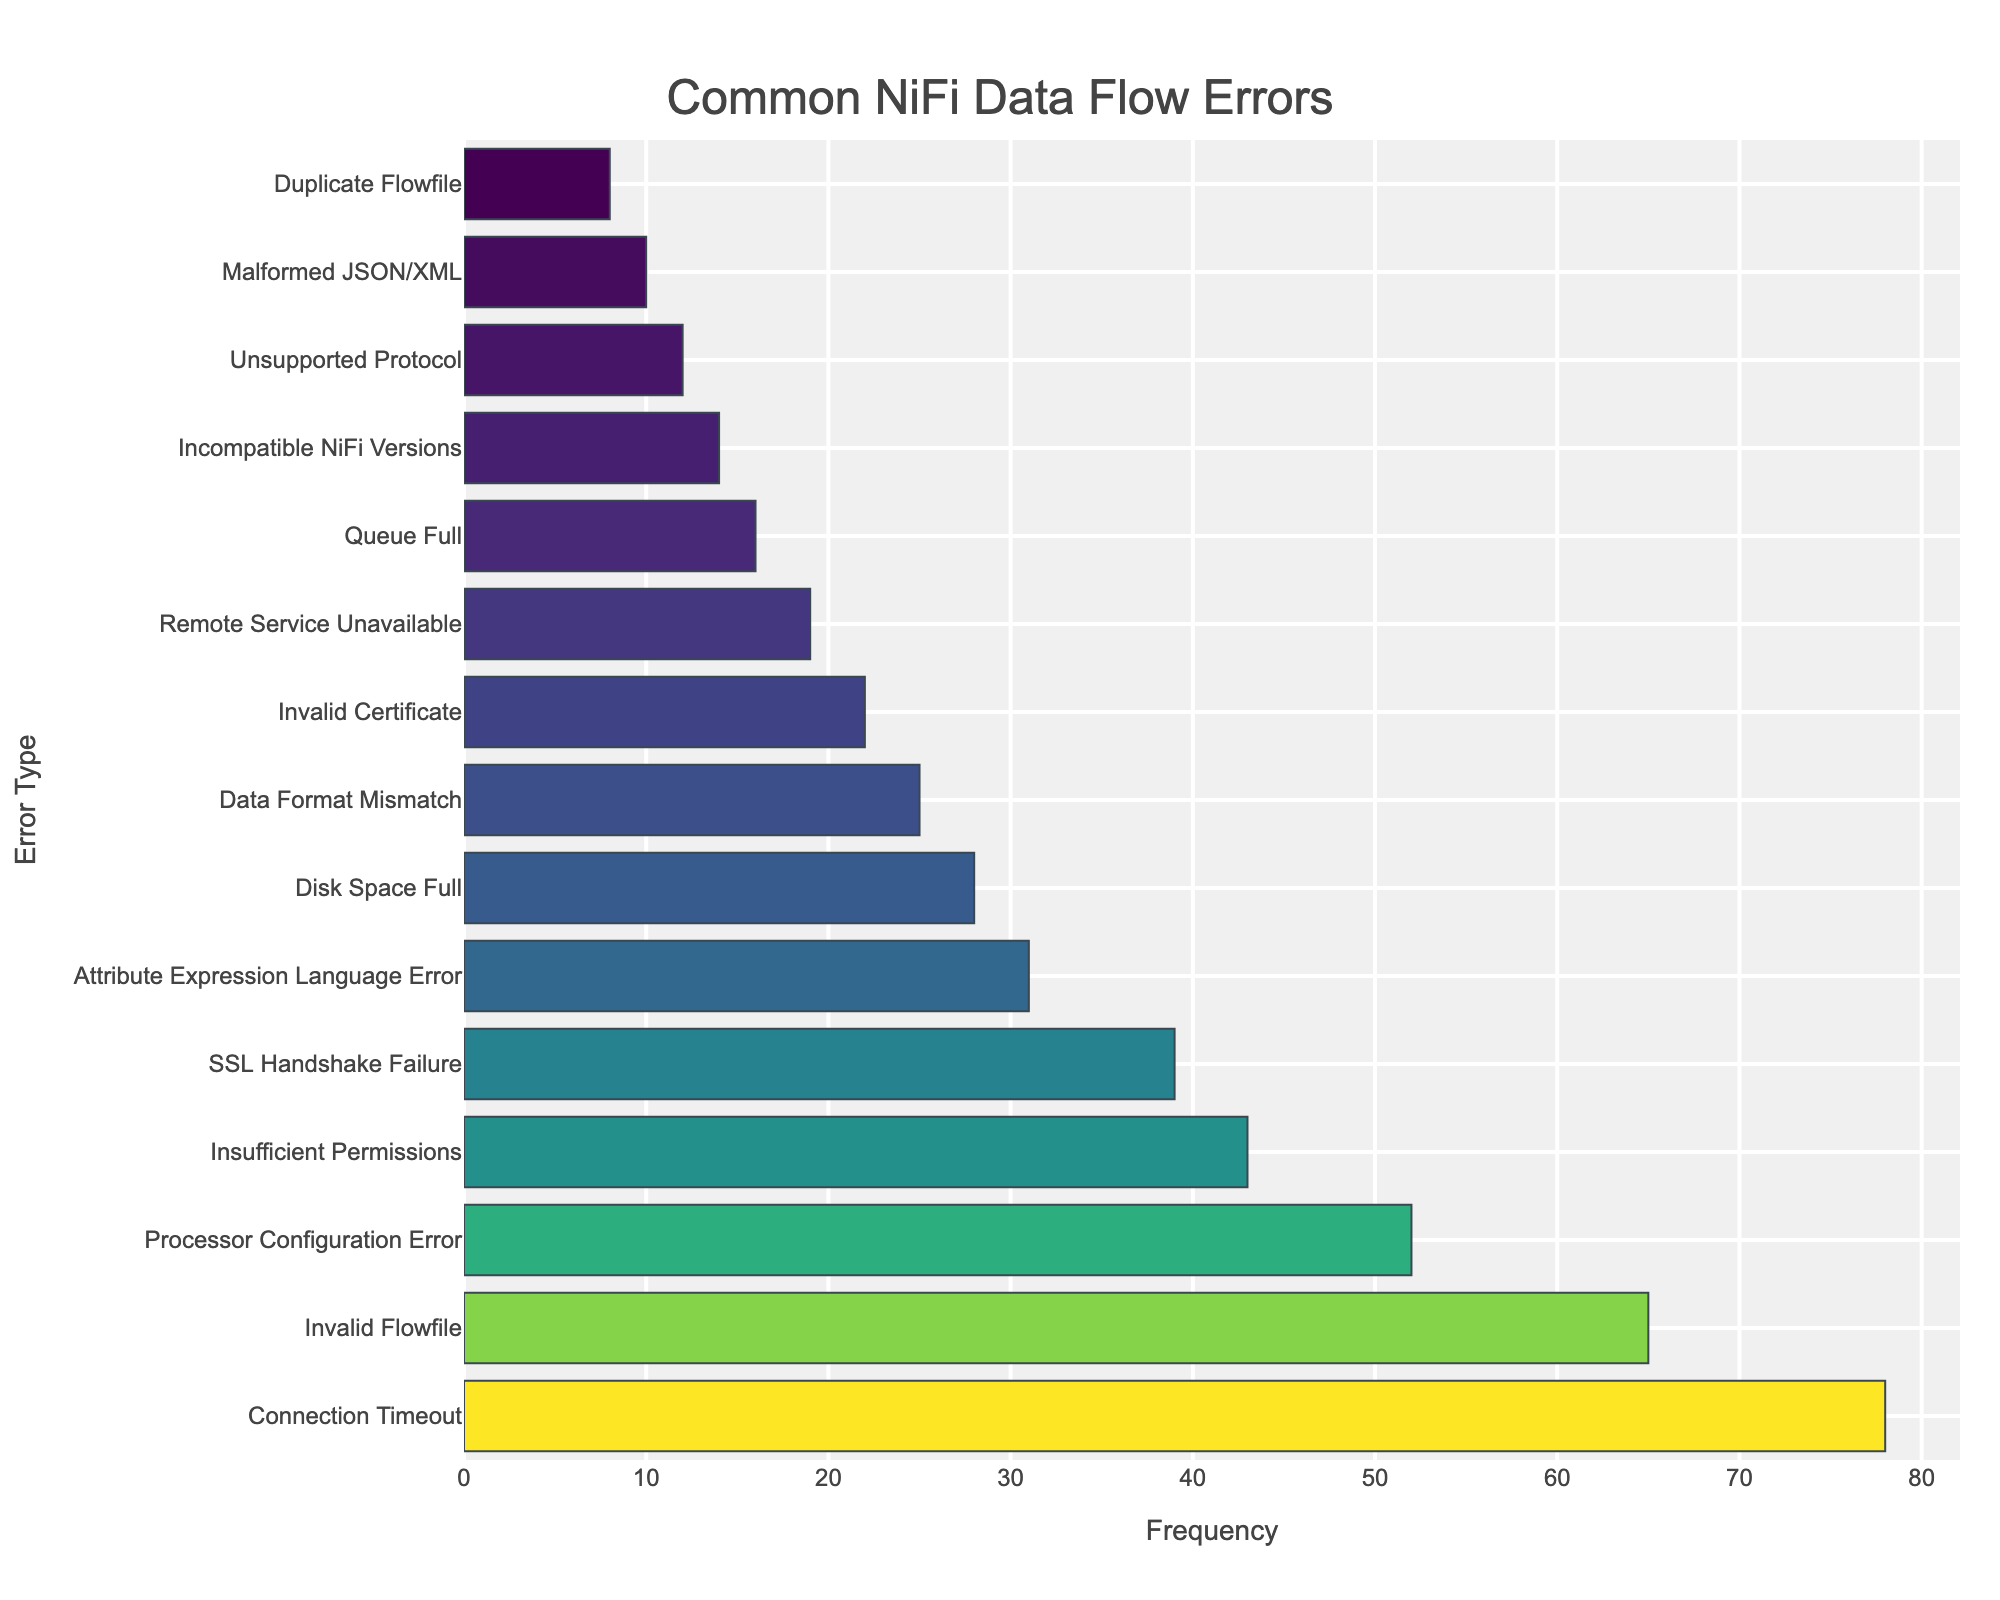What is the most common NiFi data flow error? By examining the bar with the highest length in the chart, the error "Connection Timeout" occurs the most frequently at 78 times.
Answer: Connection Timeout Which error has a higher frequency: "Processor Configuration Error" or "Invalid Flowfile"? By comparing the lengths of the bars, "Invalid Flowfile" occurs 65 times, while "Processor Configuration Error" occurs 52 times. Therefore, "Invalid Flowfile" has a higher frequency.
Answer: Invalid Flowfile How many total occurrences do "Disk Space Full" and "Data Format Mismatch" errors have together? Adding the frequencies of both errors: "Disk Space Full" (28) + "Data Format Mismatch" (25) = 53.
Answer: 53 Which error is least frequent, and how often does it occur? The shortest bar represents the least frequent error, which is "Duplicate Flowfile" occurring 8 times.
Answer: Duplicate Flowfile Are there more occurrences of SSL-related issues ("SSL Handshake Failure" and "Invalid Certificate") or "Processor Configuration Error"? Summing the frequencies of SSL-related issues: "SSL Handshake Failure" (39) + "Invalid Certificate" (22) = 61. Comparing this to "Processor Configuration Error" (52), there are more SSL-related issues.
Answer: SSL-related issues What is the frequency difference between "Connection Timeout" and "Queue Full"? The frequency of "Connection Timeout" (78) minus the frequency of "Queue Full" (16) results in 62.
Answer: 62 How does the frequency of "Remote Service Unavailable" compare to "Incompatible NiFi Versions"? "Remote Service Unavailable" occurs 19 times, while "Incompatible NiFi Versions" occurs 14 times. The former is more frequent.
Answer: Remote Service Unavailable Is the frequency of "Invalid Flowfile" greater than the combined frequency of "Unsupported Protocol" and "Malformed JSON/XML"? "Invalid Flowfile" occurs 65 times. The combined frequency of "Unsupported Protocol" (12) and "Malformed JSON/XML" (10) is 22. Thus, "Invalid Flowfile" is greater.
Answer: Yes Which error related to authentication or permissions has the highest frequency, and what is that frequency? The highest frequency error related to authentication or permissions is "Insufficient Permissions," occurring 43 times.
Answer: Insufficient Permissions 